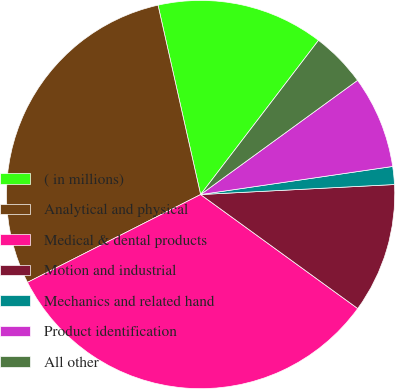Convert chart to OTSL. <chart><loc_0><loc_0><loc_500><loc_500><pie_chart><fcel>( in millions)<fcel>Analytical and physical<fcel>Medical & dental products<fcel>Motion and industrial<fcel>Mechanics and related hand<fcel>Product identification<fcel>All other<nl><fcel>13.91%<fcel>28.95%<fcel>32.54%<fcel>10.81%<fcel>1.49%<fcel>7.7%<fcel>4.6%<nl></chart> 